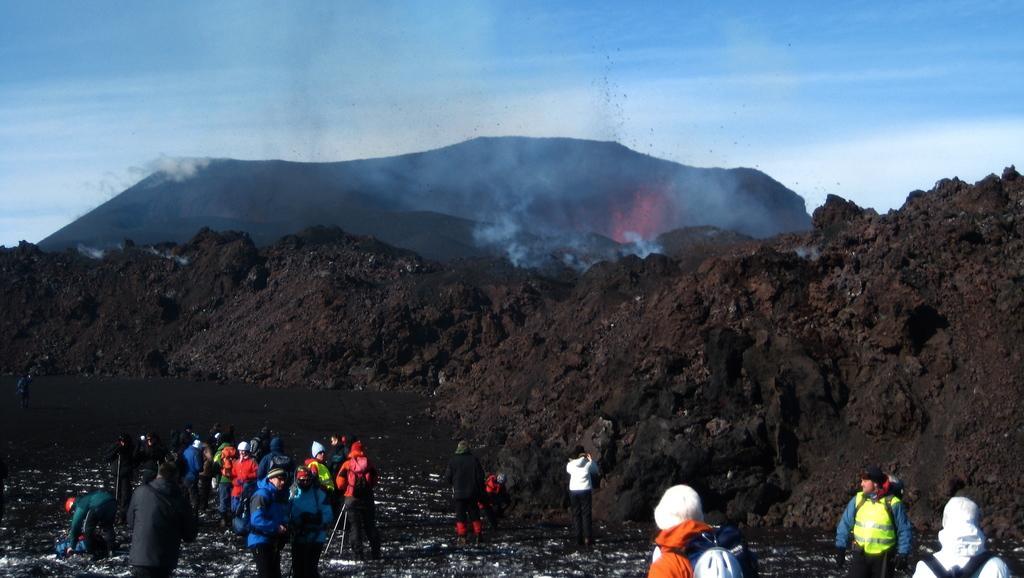Could you give a brief overview of what you see in this image? In this picture we can see a group of people and in the background we can see soil, mountains, sky. 